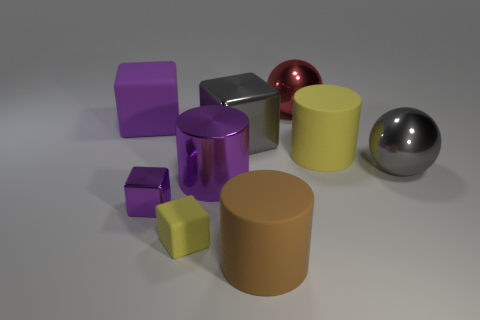Subtract 1 blocks. How many blocks are left? 3 Subtract all cylinders. How many objects are left? 6 Add 8 tiny yellow cubes. How many tiny yellow cubes exist? 9 Subtract 1 yellow cylinders. How many objects are left? 8 Subtract all purple metal blocks. Subtract all tiny cubes. How many objects are left? 6 Add 8 rubber cubes. How many rubber cubes are left? 10 